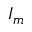Convert formula to latex. <formula><loc_0><loc_0><loc_500><loc_500>I _ { m }</formula> 